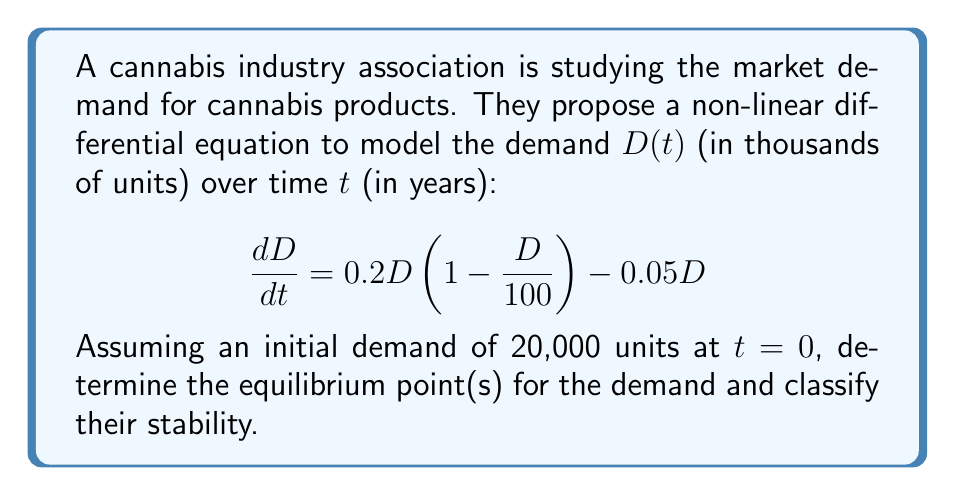Can you answer this question? To solve this problem, we'll follow these steps:

1) First, let's identify the equilibrium points by setting $\frac{dD}{dt} = 0$:

   $$0 = 0.2D(1 - \frac{D}{100}) - 0.05D$$

2) Factoring out $D$:

   $$0 = D(0.2 - 0.002D - 0.05)$$
   $$0 = D(0.15 - 0.002D)$$

3) Solving this equation:
   
   Either $D = 0$ or $0.15 - 0.002D = 0$
   
   From the second equation: $D = 75$

   So, the equilibrium points are $D = 0$ and $D = 75$ (thousand units).

4) To classify the stability, we need to evaluate $\frac{d}{dD}(\frac{dD}{dt})$ at each equilibrium point:

   $$\frac{d}{dD}(\frac{dD}{dt}) = 0.2 - 0.004D - 0.05 = 0.15 - 0.004D$$

5) At $D = 0$:
   
   $0.15 - 0.004(0) = 0.15 > 0$, so this is an unstable equilibrium point.

6) At $D = 75$:
   
   $0.15 - 0.004(75) = -0.15 < 0$, so this is a stable equilibrium point.

Therefore, the market demand will naturally tend towards 75,000 units over time, regardless of the initial demand (except if it starts exactly at 0).
Answer: The equilibrium points are $D = 0$ and $D = 75$ thousand units. $D = 0$ is an unstable equilibrium, while $D = 75$ is a stable equilibrium. 